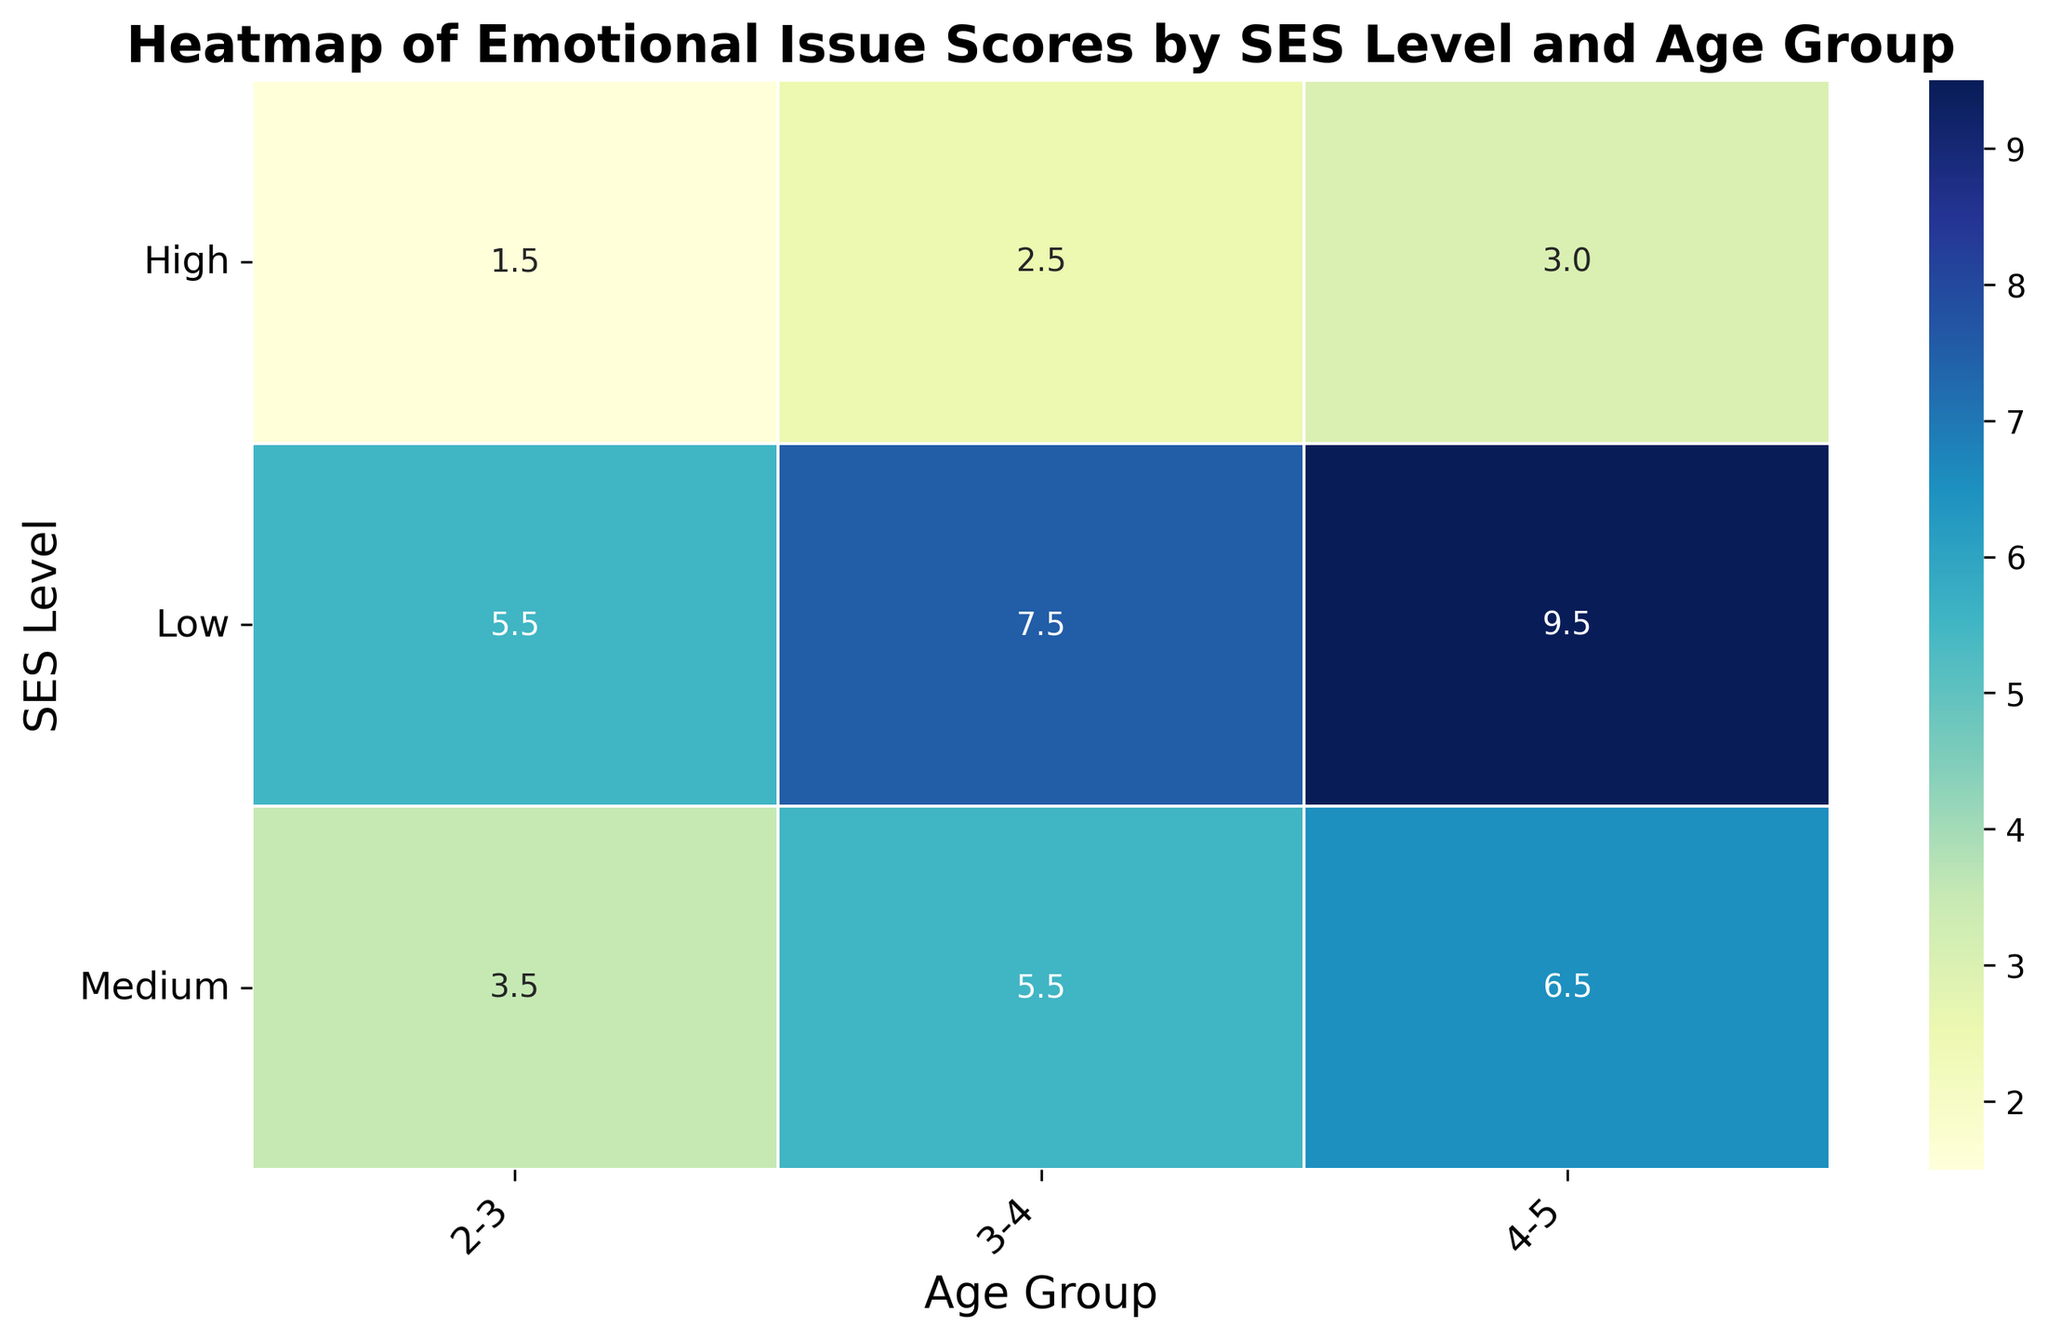What is the average Emotional Issue Score for the "Low" SES level in the "2-3" age group? First, locate the cell where SES Level is "Low" and Age Group is "2-3". The corresponding value is 5.5.
Answer: 5.5 Which SES Level has the highest average Emotional Issue Score for the "3-4" age group? Look at the values in the "3-4" column and identify the highest value, which is found in the "Low" SES level with 7.0.
Answer: Low What is the difference in average Emotional Issue Scores between the "Low" and "High" SES levels for the "4-5" age group? Find the average scores for the "Low" and "High" SES levels in the "4-5" age group, which are 9.5 and 3.0 respectively. The difference is 9.5 - 3.0 = 6.5.
Answer: 6.5 Which Age Group has the lowest average Emotional Issue Score in the "Medium" SES level? Look at the values in the "Medium" SES row across all age groups and identify the lowest value, which is in the "2-3" age group with 3.5.
Answer: 2-3 Is the average Emotional Issue Score for "High" SES level in the "3-4" age group higher or lower than the score for "Medium" SES level in the "2-3" age group? Compare the scores: "High" in "3-4" is 2.5, and "Medium" in "2-3" is 3.5. Since 2.5 < 3.5, the score for "High" SES level in "3-4" is lower.
Answer: Lower Are the average Emotional Issue Scores for the "High" SES Level consistent across all age groups? Look at the values in the "High" SES row across all age groups, which are 1.5, 2.5, and 3.0. They are not consistent as they vary between the values.
Answer: No What is the combined average Emotional Issue Score for the "Low" SES level across all age groups? Calculate the average score for each age group in the "Low" SES level: (5.5 + 7.5 + 9.5) / 3 = 7.5.
Answer: 7.5 Which Age Group shows the greatest variation in average Emotional Issue Scores across different SES levels? Examine each age group: "2-3" (5.5 - 1.5 = 4), "3-4" (7.0 - 2.5 = 4.5), "4-5" (9.5 - 3.0 = 6.5). The "4-5" age group has the largest variation of 6.5.
Answer: 4-5 What color represents the highest average Emotional Issue Scores on the heatmap? Identify the color associated with the highest numerical value on the heatmap, which corresponds to the darkest shade of blue.
Answer: Dark blue 